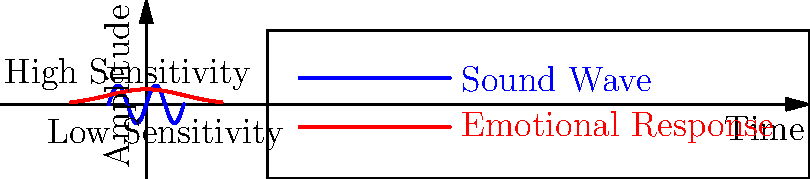In the graph above, the blue sine wave represents a sound wave, while the red curve represents an emotional response. How does the emotional response curve reflect the sensitivity of a person to different sound intensities over time? To understand how the emotional response curve reflects sensitivity:

1. Observe the shape of the red curve (emotional response):
   - It's a bell-shaped curve, peaking in the center and tapering off at the edges.

2. Compare the emotional response to the sound wave:
   - The sound wave (blue) has constant amplitude throughout.
   - The emotional response (red) varies in intensity.

3. Analyze the center of the graph:
   - The emotional response is highest when the sound wave is near its equilibrium (center).
   - This suggests heightened sensitivity to subtle changes in sound.

4. Look at the edges of the graph:
   - The emotional response decreases as the sound wave reaches its peaks and troughs.
   - This indicates lower sensitivity to extreme sound intensities.

5. Consider the overall relationship:
   - The emotional response is strongest for moderate sounds.
   - It diminishes for very loud or very quiet sounds.

6. Interpret for a sensitive person:
   - The peak of the red curve represents high emotional reactivity to subtle sound changes.
   - The tapered ends show a tendency to become overwhelmed and less responsive to extreme stimuli.

This graph illustrates how a sensitive person might be highly attuned to nuanced changes in their environment (center of the curve) but may shut down or become less responsive when stimuli become too intense (edges of the curve).
Answer: The bell-shaped emotional response curve peaks for subtle sound changes, decreasing for extreme intensities, reflecting high sensitivity to nuanced stimuli but reduced responsiveness to overwhelming sounds. 